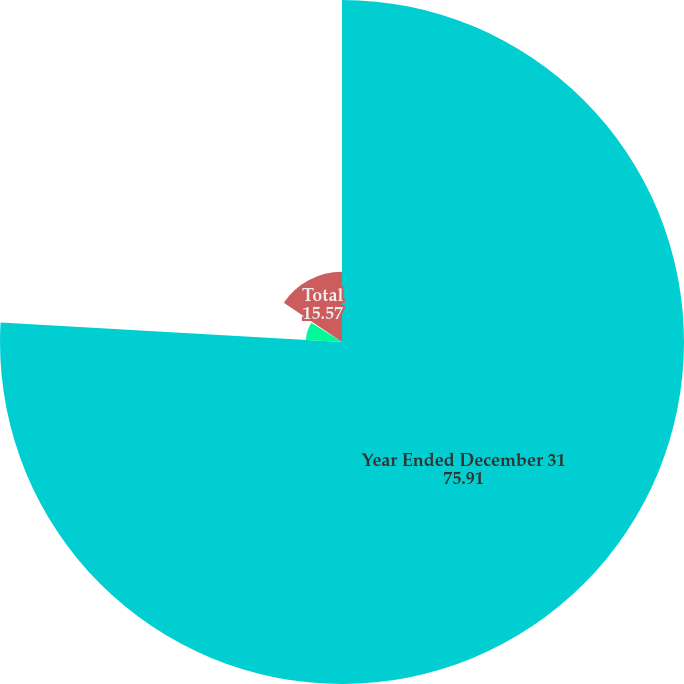Convert chart. <chart><loc_0><loc_0><loc_500><loc_500><pie_chart><fcel>Year Ended December 31<fcel>Andes SBU<fcel>Eurasia SBU<fcel>Total<nl><fcel>75.91%<fcel>8.03%<fcel>0.49%<fcel>15.57%<nl></chart> 